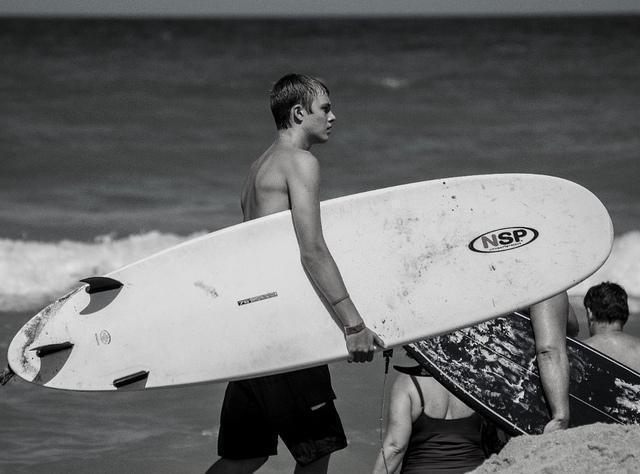What are the black triangular pieces on the board called?
Indicate the correct choice and explain in the format: 'Answer: answer
Rationale: rationale.'
Options: Wings, hooks, traps, fins. Answer: fins.
Rationale: A surfboard has projections to help with balance on one end. 